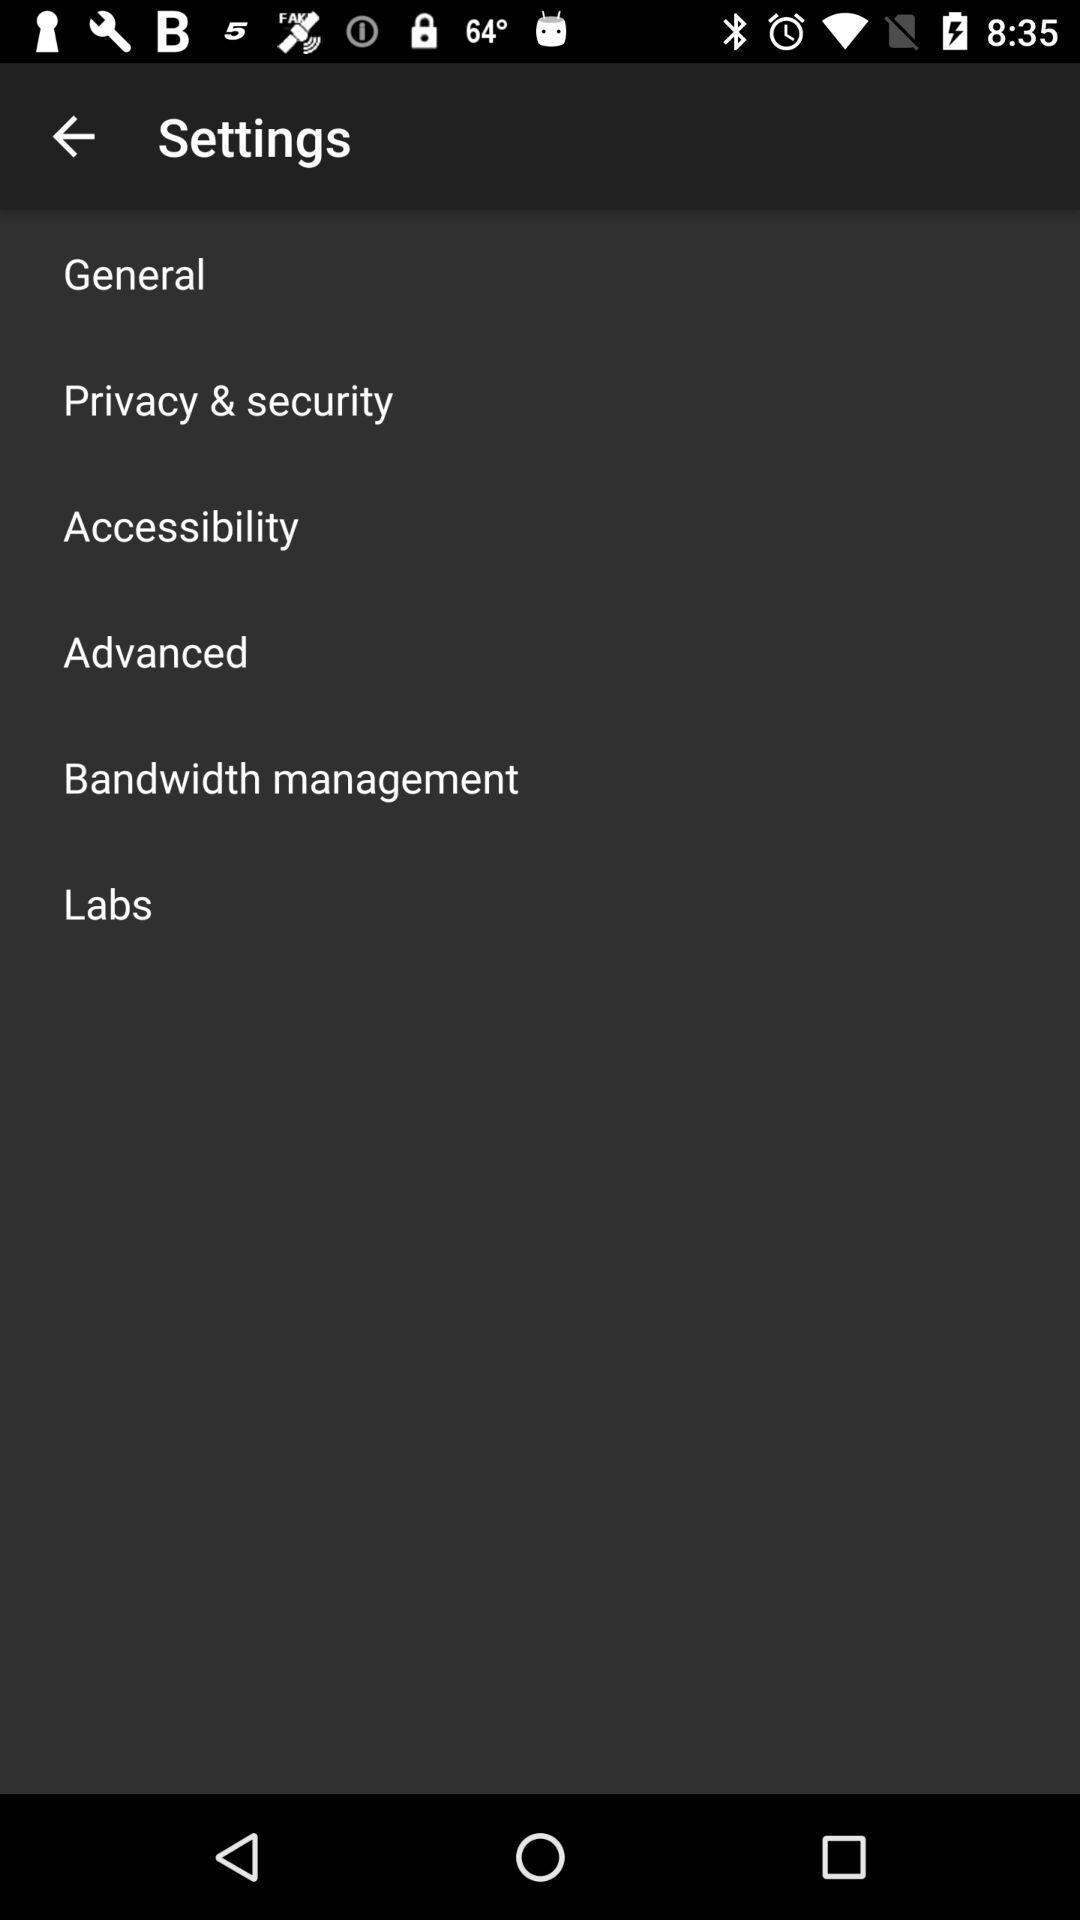How many items are in the settings menu?
Answer the question using a single word or phrase. 6 